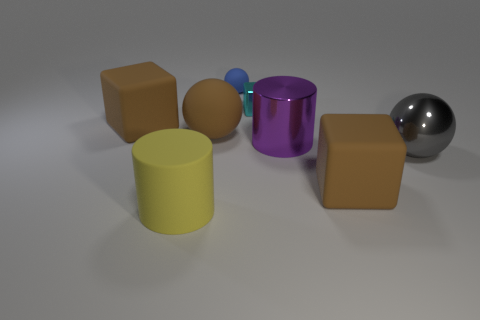Subtract all gray shiny balls. How many balls are left? 2 Subtract all brown balls. How many brown blocks are left? 2 Add 1 cyan metallic cubes. How many objects exist? 9 Subtract all purple cubes. Subtract all gray spheres. How many cubes are left? 3 Subtract all tiny blue things. Subtract all yellow matte objects. How many objects are left? 6 Add 1 big purple metal cylinders. How many big purple metal cylinders are left? 2 Add 4 cyan blocks. How many cyan blocks exist? 5 Subtract 0 gray cubes. How many objects are left? 8 Subtract all cylinders. How many objects are left? 6 